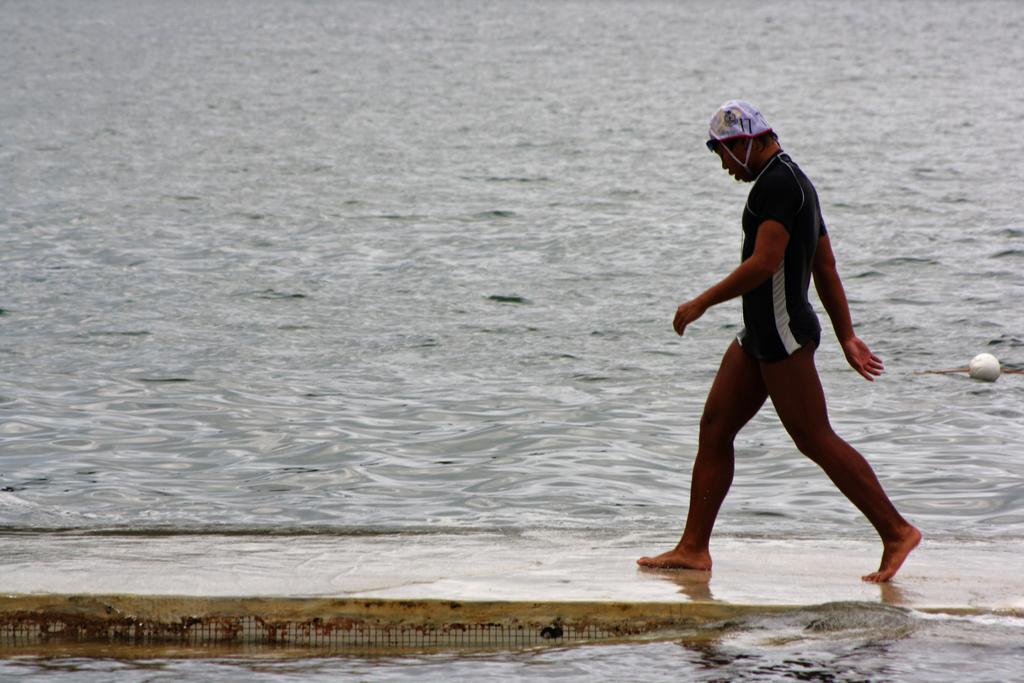What is happening in the image? There is a person in the image, and they are walking on a floor. Can you describe the environment in the image? There is water visible in the image. What type of pen is the person using to write on the water in the image? There is no pen or writing activity present in the image; the person is simply walking on a floor with water visible. 